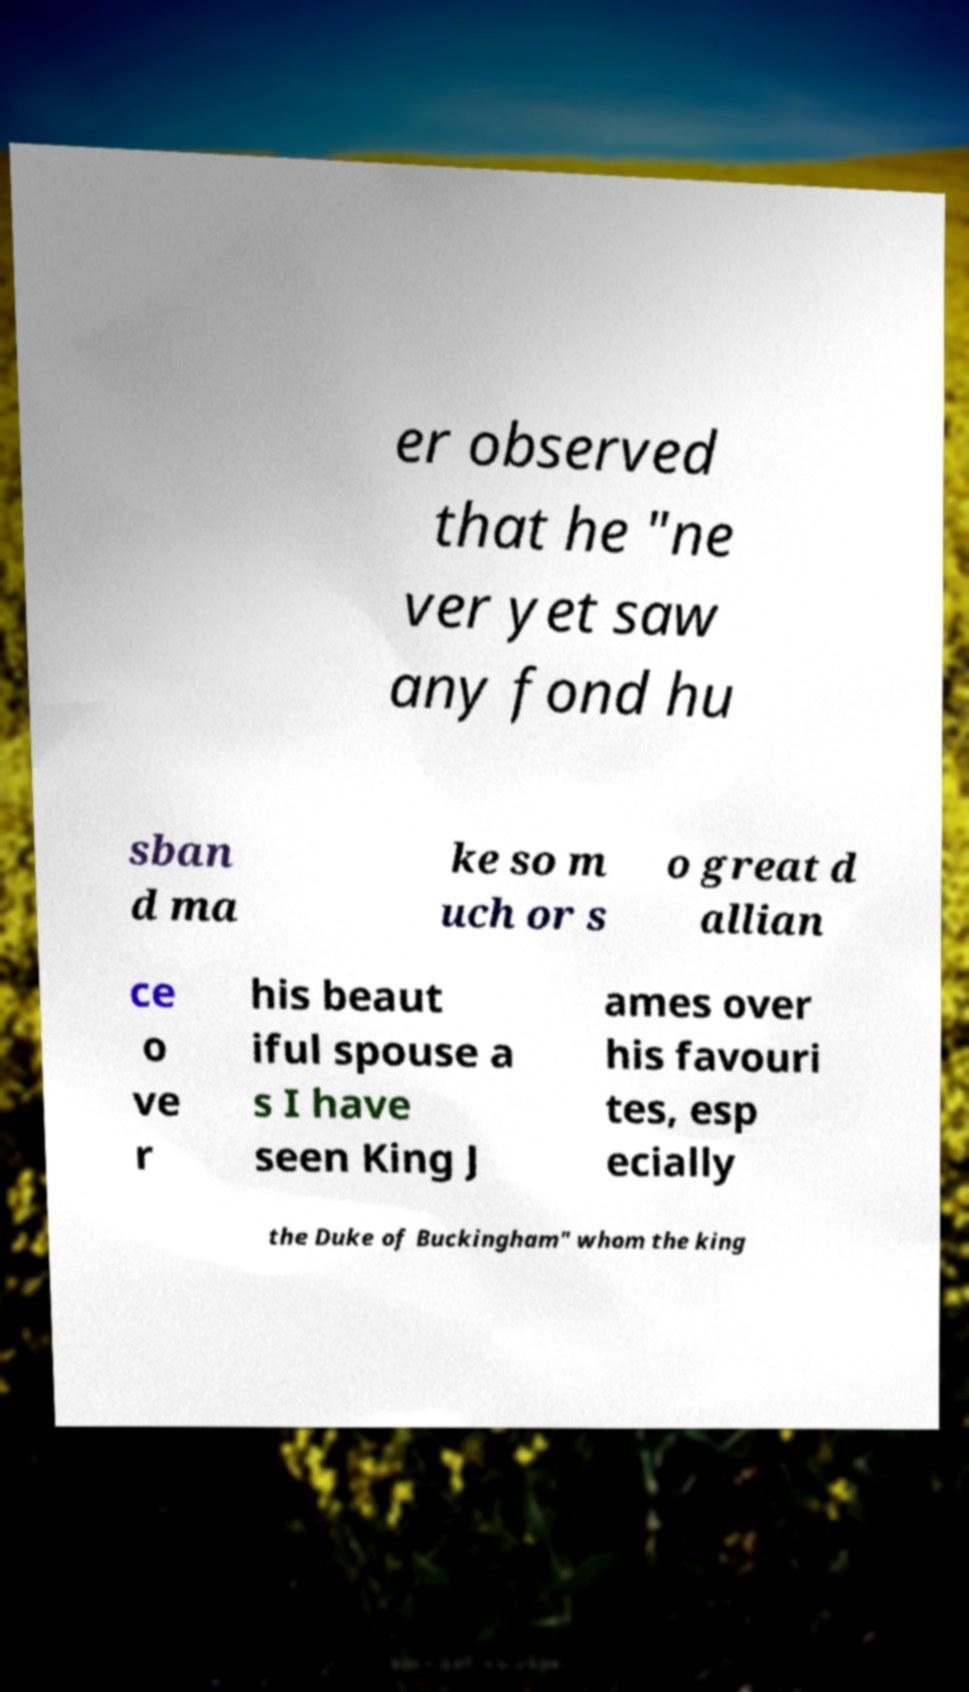Can you accurately transcribe the text from the provided image for me? er observed that he "ne ver yet saw any fond hu sban d ma ke so m uch or s o great d allian ce o ve r his beaut iful spouse a s I have seen King J ames over his favouri tes, esp ecially the Duke of Buckingham" whom the king 